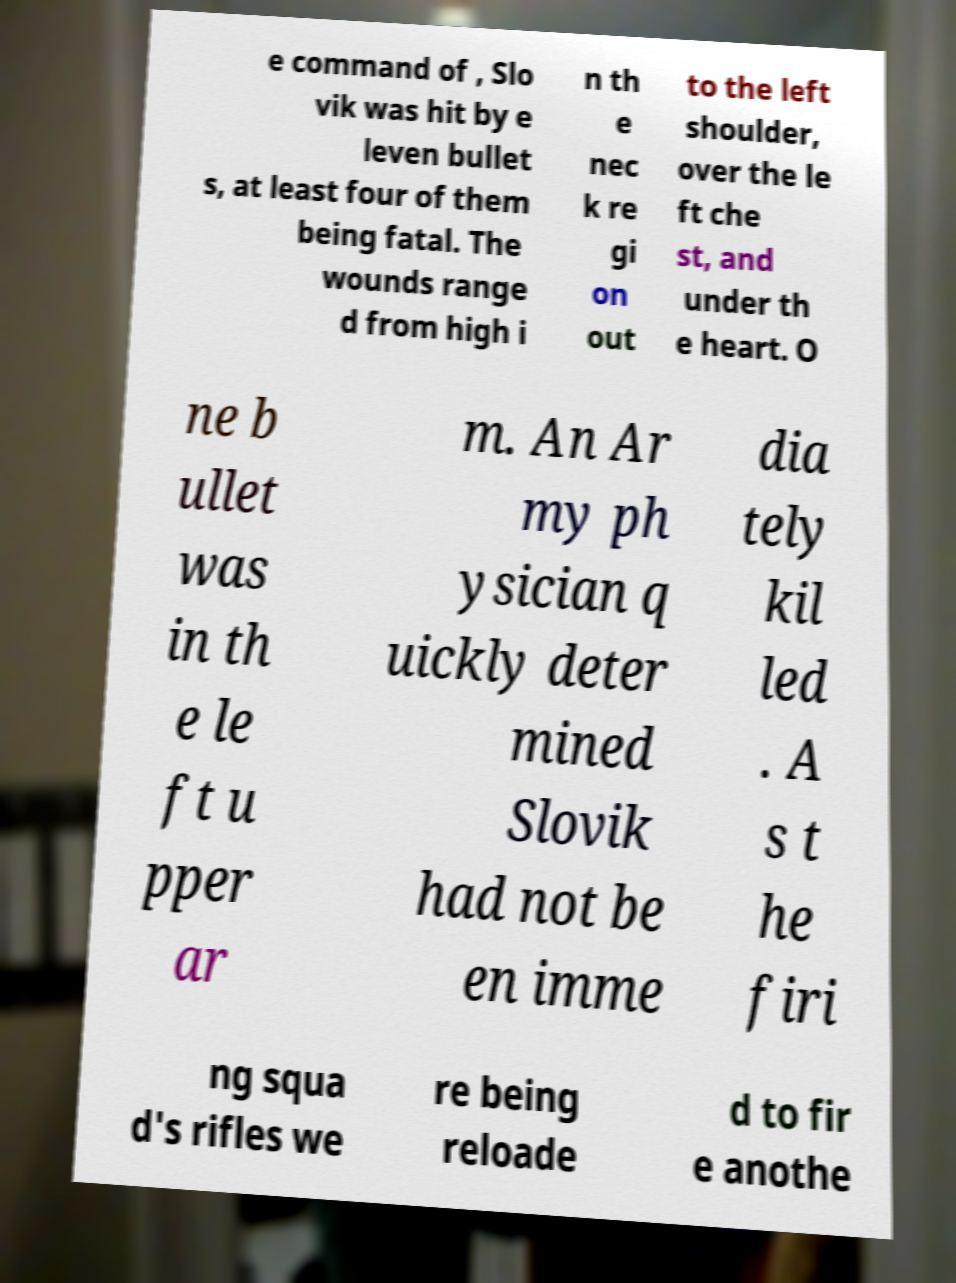For documentation purposes, I need the text within this image transcribed. Could you provide that? e command of , Slo vik was hit by e leven bullet s, at least four of them being fatal. The wounds range d from high i n th e nec k re gi on out to the left shoulder, over the le ft che st, and under th e heart. O ne b ullet was in th e le ft u pper ar m. An Ar my ph ysician q uickly deter mined Slovik had not be en imme dia tely kil led . A s t he firi ng squa d's rifles we re being reloade d to fir e anothe 